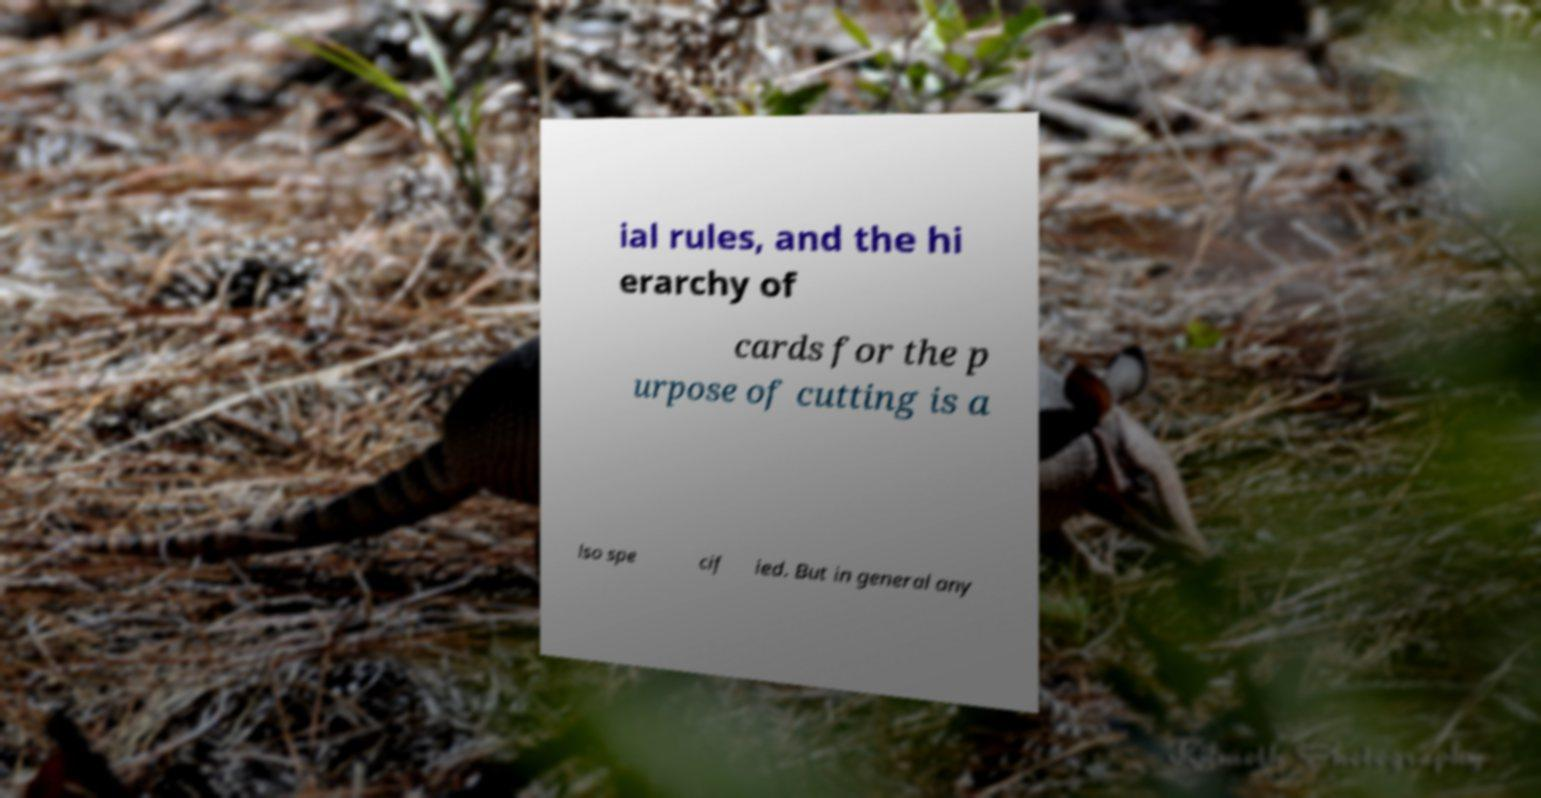Could you extract and type out the text from this image? ial rules, and the hi erarchy of cards for the p urpose of cutting is a lso spe cif ied. But in general any 